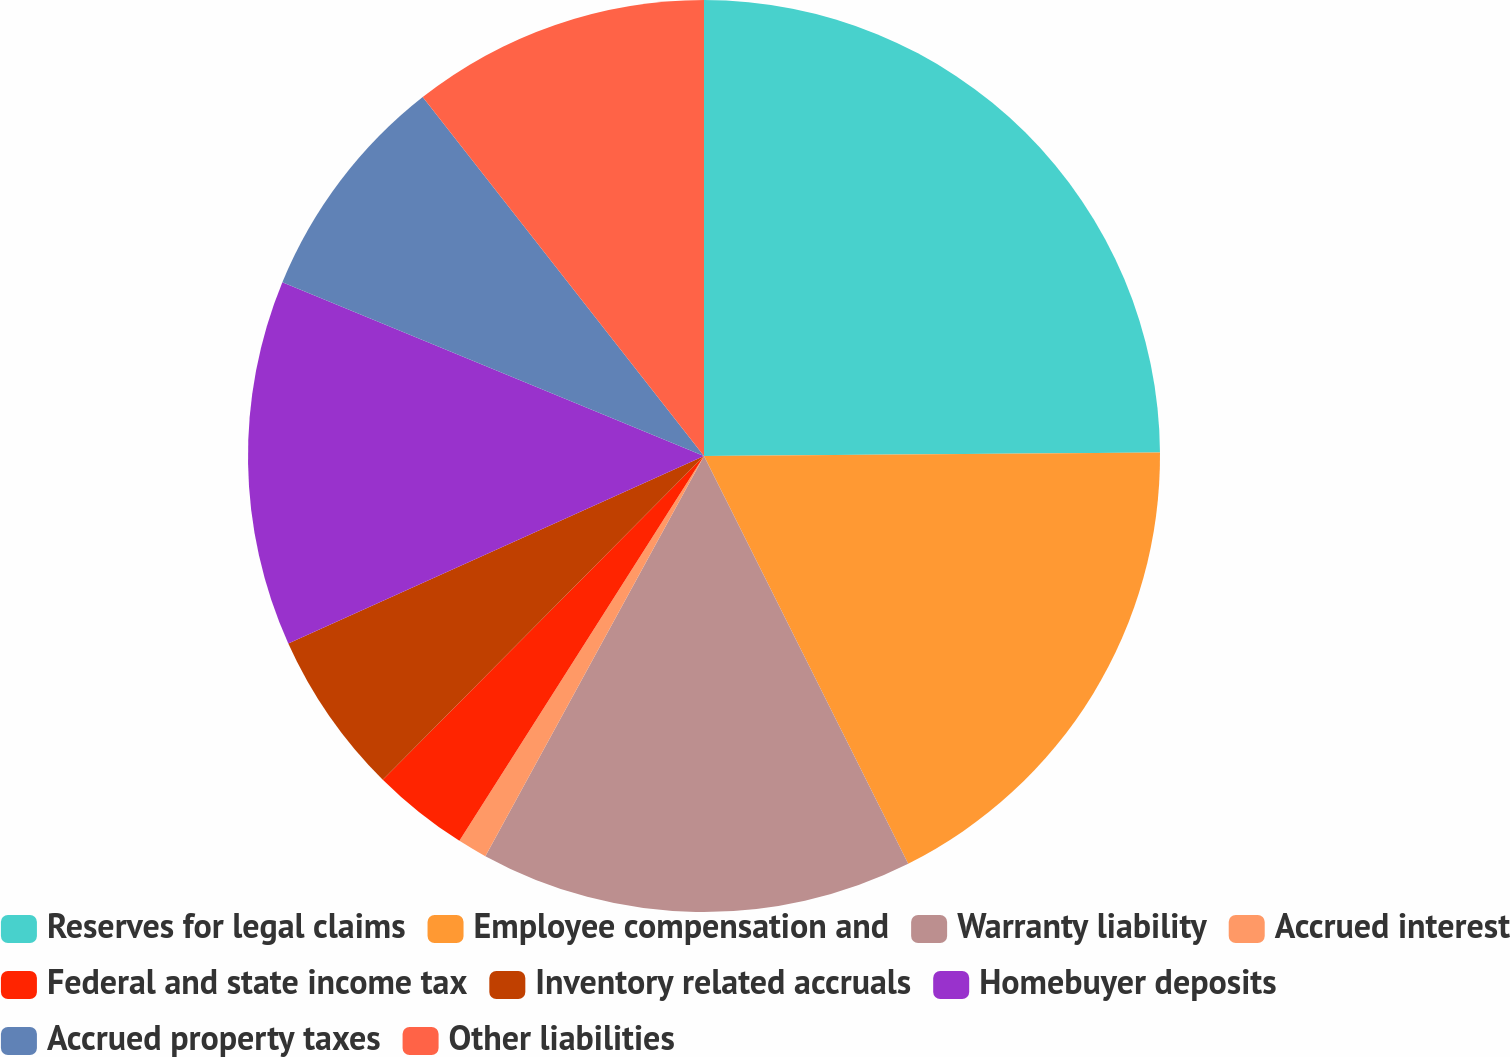Convert chart to OTSL. <chart><loc_0><loc_0><loc_500><loc_500><pie_chart><fcel>Reserves for legal claims<fcel>Employee compensation and<fcel>Warranty liability<fcel>Accrued interest<fcel>Federal and state income tax<fcel>Inventory related accruals<fcel>Homebuyer deposits<fcel>Accrued property taxes<fcel>Other liabilities<nl><fcel>24.88%<fcel>17.73%<fcel>15.35%<fcel>1.05%<fcel>3.43%<fcel>5.82%<fcel>12.96%<fcel>8.2%<fcel>10.58%<nl></chart> 